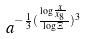<formula> <loc_0><loc_0><loc_500><loc_500>a ^ { - \frac { 1 } { 3 } ( \frac { \log \frac { x } { x _ { 8 } } } { \log \Xi } ) ^ { 3 } }</formula> 